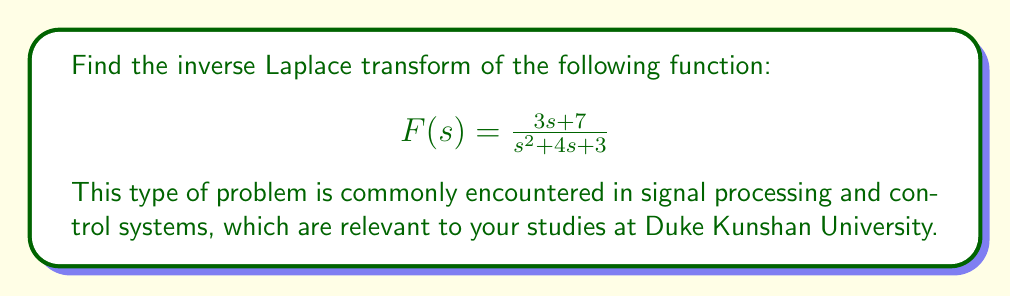Give your solution to this math problem. To find the inverse Laplace transform, we'll use partial fraction decomposition:

1) First, factor the denominator:
   $$s^2 + 4s + 3 = (s+1)(s+3)$$

2) Set up the partial fraction decomposition:
   $$\frac{3s + 7}{(s+1)(s+3)} = \frac{A}{s+1} + \frac{B}{s+3}$$

3) Multiply both sides by $(s+1)(s+3)$:
   $$3s + 7 = A(s+3) + B(s+1)$$

4) Expand the right side:
   $$3s + 7 = As + 3A + Bs + B$$

5) Collect like terms:
   $$3s + 7 = (A+B)s + (3A+B)$$

6) Equate coefficients:
   $3 = A+B$
   $7 = 3A+B$

7) Solve the system of equations:
   Subtracting the first equation from the second:
   $4 = 2A$
   $A = 2$
   
   Substituting back:
   $3 = 2+B$
   $B = 1$

8) Our partial fraction decomposition is:
   $$F(s) = \frac{2}{s+1} + \frac{1}{s+3}$$

9) Now we can use the linearity property of the inverse Laplace transform and the standard inverse Laplace transform pairs:

   $\mathcal{L}^{-1}\{\frac{1}{s+a}\} = e^{-at}$

   Therefore:
   $$\mathcal{L}^{-1}\{F(s)\} = 2e^{-t} + e^{-3t}$$
Answer: $$f(t) = 2e^{-t} + e^{-3t}$$ 